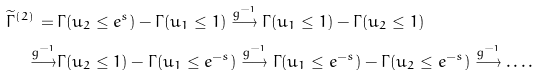Convert formula to latex. <formula><loc_0><loc_0><loc_500><loc_500>\widetilde { \Gamma } ^ { ( 2 ) } \, = \, & \Gamma ( u _ { 2 } \leq e ^ { s } ) - \Gamma ( u _ { 1 } \leq 1 ) \overset { g ^ { - 1 } } { \longrightarrow } \Gamma ( u _ { 1 } \leq 1 ) - \Gamma ( u _ { 2 } \leq 1 ) \\ \overset { g ^ { - 1 } } { \longrightarrow } & \Gamma ( u _ { 2 } \leq 1 ) - \Gamma ( u _ { 1 } \leq e ^ { - s } ) \overset { g ^ { - 1 } } { \longrightarrow } \Gamma ( u _ { 1 } \leq e ^ { - s } ) - \Gamma ( u _ { 2 } \leq e ^ { - s } ) \overset { g ^ { - 1 } } { \longrightarrow } \dots .</formula> 